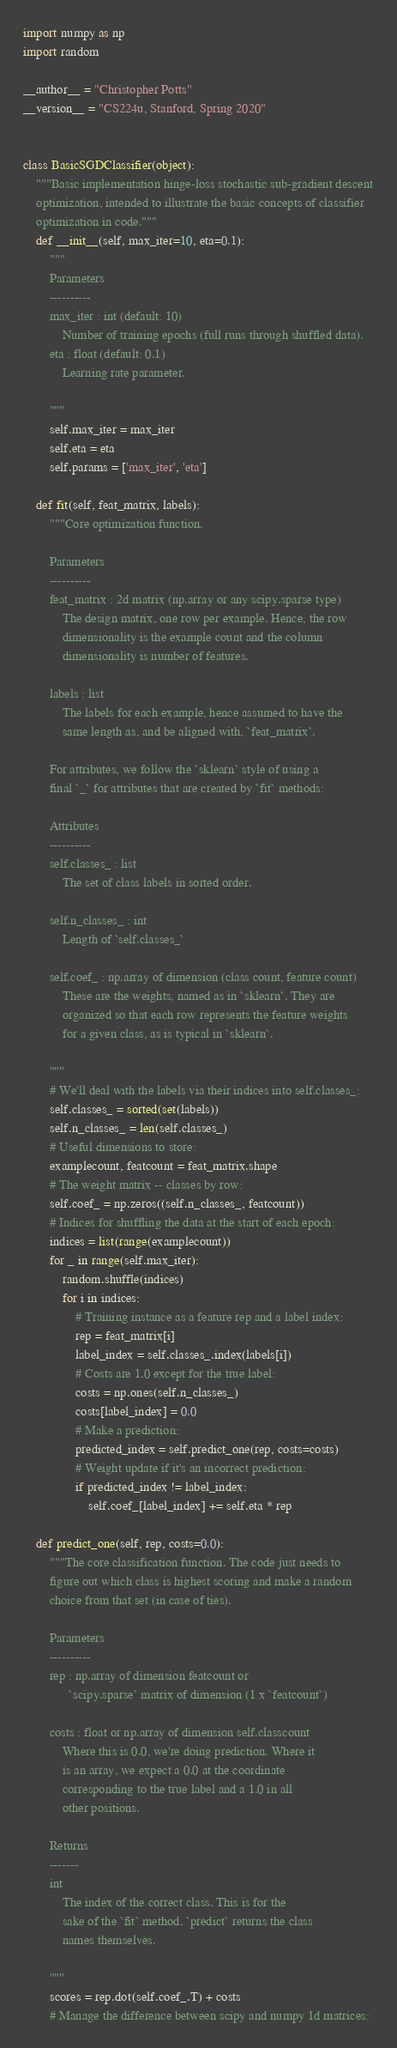<code> <loc_0><loc_0><loc_500><loc_500><_Python_>import numpy as np
import random

__author__ = "Christopher Potts"
__version__ = "CS224u, Stanford, Spring 2020"


class BasicSGDClassifier(object):
    """Basic implementation hinge-loss stochastic sub-gradient descent
    optimization, intended to illustrate the basic concepts of classifier
    optimization in code."""
    def __init__(self, max_iter=10, eta=0.1):
        """
        Parameters
        ----------
        max_iter : int (default: 10)
            Number of training epochs (full runs through shuffled data).
        eta : float (default: 0.1)
            Learning rate parameter.

        """
        self.max_iter = max_iter
        self.eta = eta
        self.params = ['max_iter', 'eta']

    def fit(self, feat_matrix, labels):
        """Core optimization function.

        Parameters
        ----------
        feat_matrix : 2d matrix (np.array or any scipy.sparse type)
            The design matrix, one row per example. Hence, the row
            dimensionality is the example count and the column
            dimensionality is number of features.

        labels : list
            The labels for each example, hence assumed to have the
            same length as, and be aligned with, `feat_matrix`.

        For attributes, we follow the `sklearn` style of using a
        final `_` for attributes that are created by `fit` methods:

        Attributes
        ----------
        self.classes_ : list
            The set of class labels in sorted order.

        self.n_classes_ : int
            Length of `self.classes_`

        self.coef_ : np.array of dimension (class count, feature count)
            These are the weights, named as in `sklearn`. They are
            organized so that each row represents the feature weights
            for a given class, as is typical in `sklearn`.

        """
        # We'll deal with the labels via their indices into self.classes_:
        self.classes_ = sorted(set(labels))
        self.n_classes_ = len(self.classes_)
        # Useful dimensions to store:
        examplecount, featcount = feat_matrix.shape
        # The weight matrix -- classes by row:
        self.coef_ = np.zeros((self.n_classes_, featcount))
        # Indices for shuffling the data at the start of each epoch:
        indices = list(range(examplecount))
        for _ in range(self.max_iter):
            random.shuffle(indices)
            for i in indices:
                # Training instance as a feature rep and a label index:
                rep = feat_matrix[i]
                label_index = self.classes_.index(labels[i])
                # Costs are 1.0 except for the true label:
                costs = np.ones(self.n_classes_)
                costs[label_index] = 0.0
                # Make a prediction:
                predicted_index = self.predict_one(rep, costs=costs)
                # Weight update if it's an incorrect prediction:
                if predicted_index != label_index:
                    self.coef_[label_index] += self.eta * rep

    def predict_one(self, rep, costs=0.0):
        """The core classification function. The code just needs to
        figure out which class is highest scoring and make a random
        choice from that set (in case of ties).

        Parameters
        ----------
        rep : np.array of dimension featcount or
              `scipy.sparse` matrix of dimension (1 x `featcount`)

        costs : float or np.array of dimension self.classcount
            Where this is 0.0, we're doing prediction. Where it
            is an array, we expect a 0.0 at the coordinate
            corresponding to the true label and a 1.0 in all
            other positions.

        Returns
        -------
        int
            The index of the correct class. This is for the
            sake of the `fit` method. `predict` returns the class
            names themselves.

        """
        scores = rep.dot(self.coef_.T) + costs
        # Manage the difference between scipy and numpy 1d matrices:</code> 